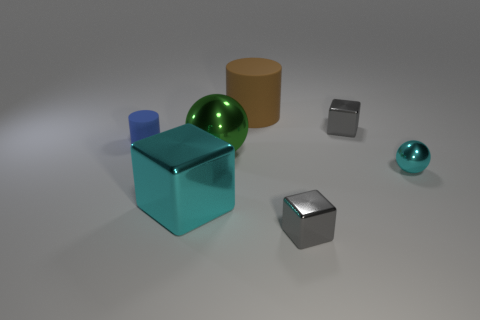There is a matte thing that is to the right of the green object; does it have the same color as the tiny cylinder?
Offer a very short reply. No. Is the number of brown objects that are in front of the blue matte thing greater than the number of small gray blocks?
Keep it short and to the point. No. Are there any other things that have the same color as the large ball?
Make the answer very short. No. There is a tiny gray metallic object that is behind the small gray metallic cube in front of the tiny cyan thing; what shape is it?
Your answer should be very brief. Cube. Are there more tiny objects than big cylinders?
Offer a terse response. Yes. What number of things are behind the blue object and in front of the big brown object?
Your answer should be compact. 1. There is a rubber cylinder that is on the right side of the big ball; what number of gray metallic cubes are left of it?
Keep it short and to the point. 0. How many objects are either tiny metallic blocks that are behind the large cyan metallic cube or metallic cubes that are behind the blue object?
Give a very brief answer. 1. What material is the other thing that is the same shape as the tiny matte object?
Make the answer very short. Rubber. How many objects are gray objects that are behind the large cyan metal thing or big purple blocks?
Give a very brief answer. 1. 